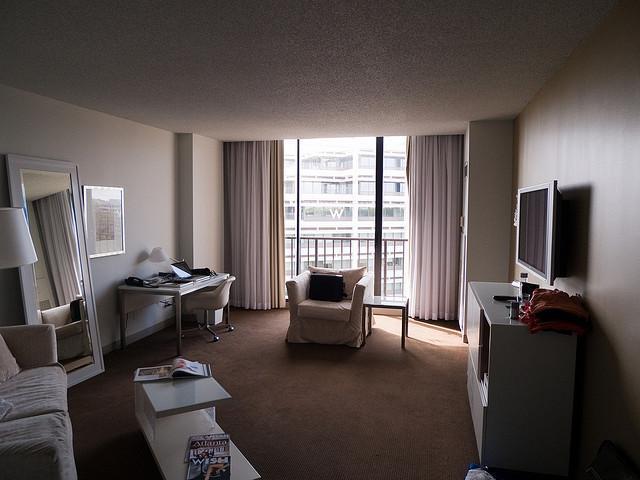How many couches are visible?
Give a very brief answer. 2. How many people are wearing black?
Give a very brief answer. 0. 